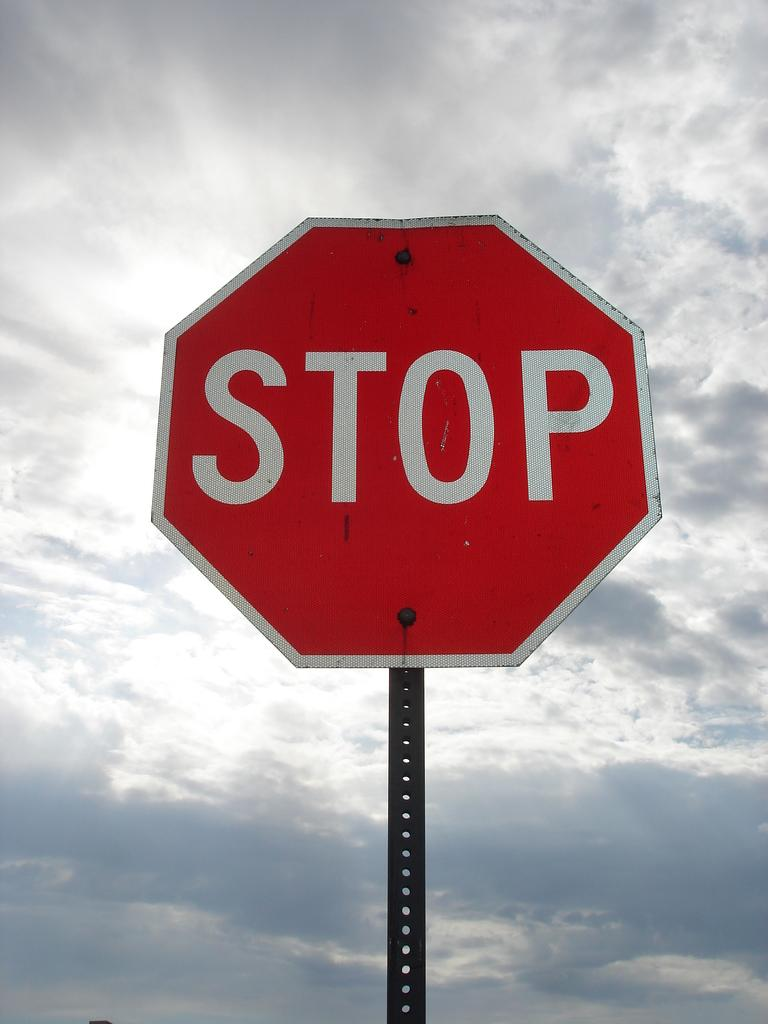Provide a one-sentence caption for the provided image. a stop sign that is outside with clouds above. 